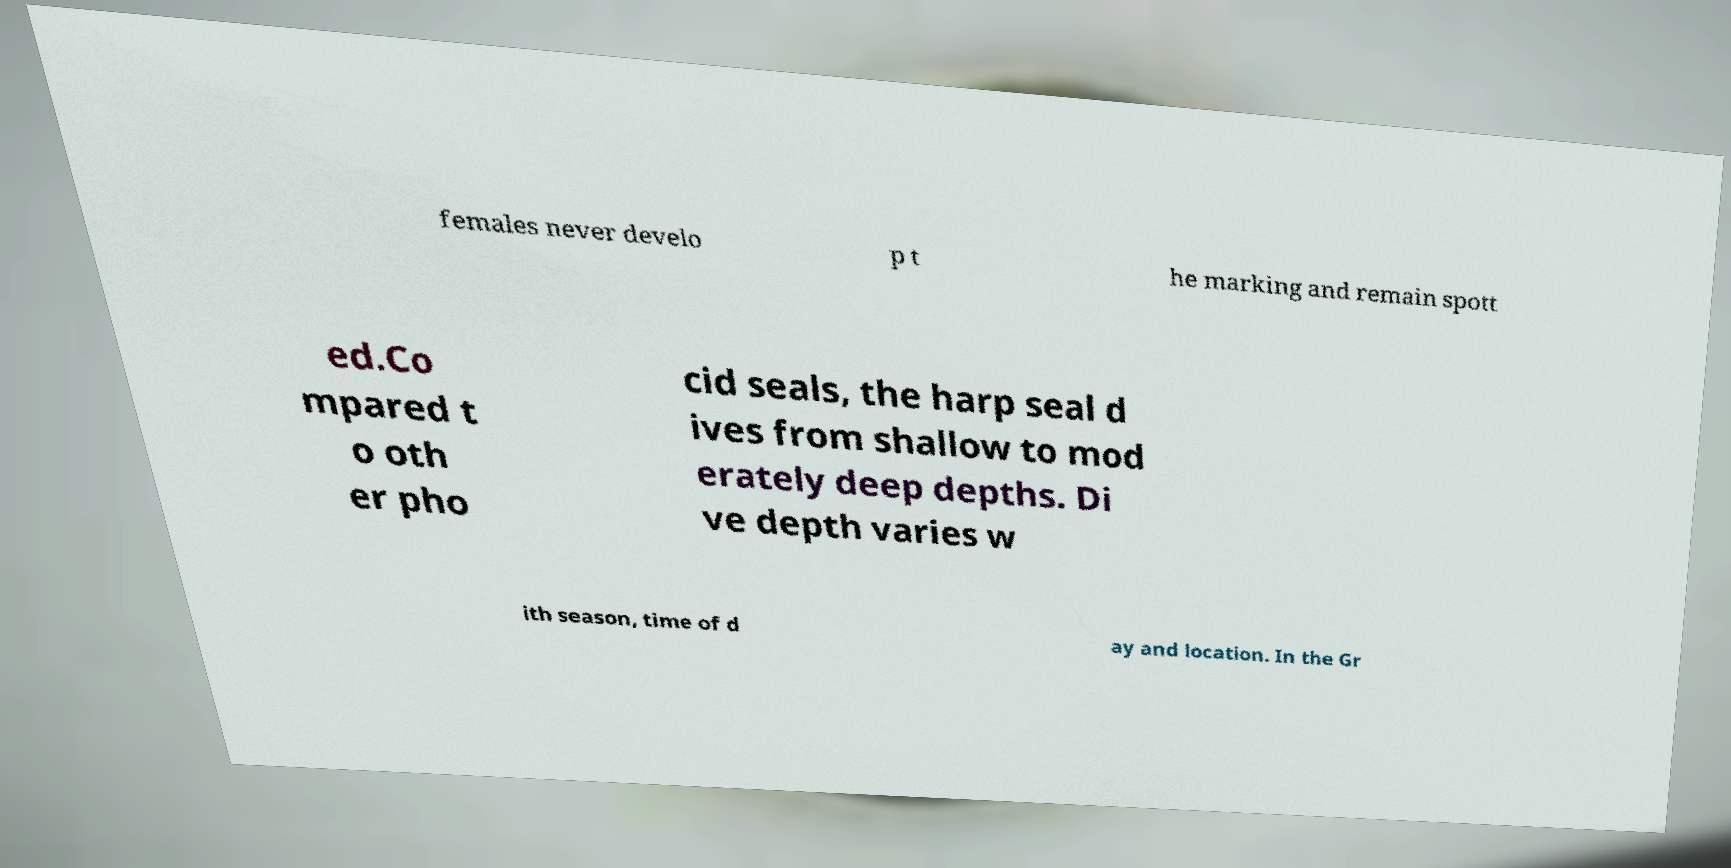Please identify and transcribe the text found in this image. females never develo p t he marking and remain spott ed.Co mpared t o oth er pho cid seals, the harp seal d ives from shallow to mod erately deep depths. Di ve depth varies w ith season, time of d ay and location. In the Gr 